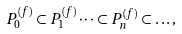Convert formula to latex. <formula><loc_0><loc_0><loc_500><loc_500>P _ { 0 } ^ { ( f ) } \subset P _ { 1 } ^ { ( f ) } \dots \subset P _ { n } ^ { ( f ) } \subset \dots ,</formula> 